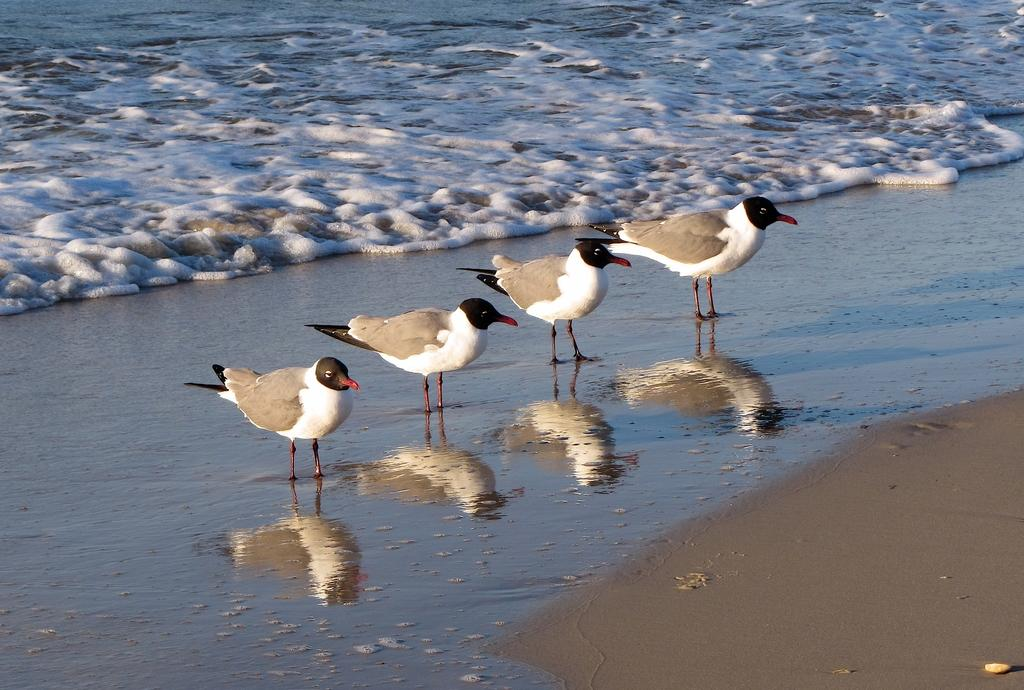What type of animals can be seen in the image? There are birds in the image. What natural element is visible towards the top of the image? There is water visible towards the top of the image. What natural element is visible towards the bottom of the image? There is sand visible towards the bottom of the image. What object can be seen on the sand? There is an object on the sand. What type of cast can be seen on the fish in the image? There are no fish or casts present in the image; it features birds, water, sand, and an object on the sand. 